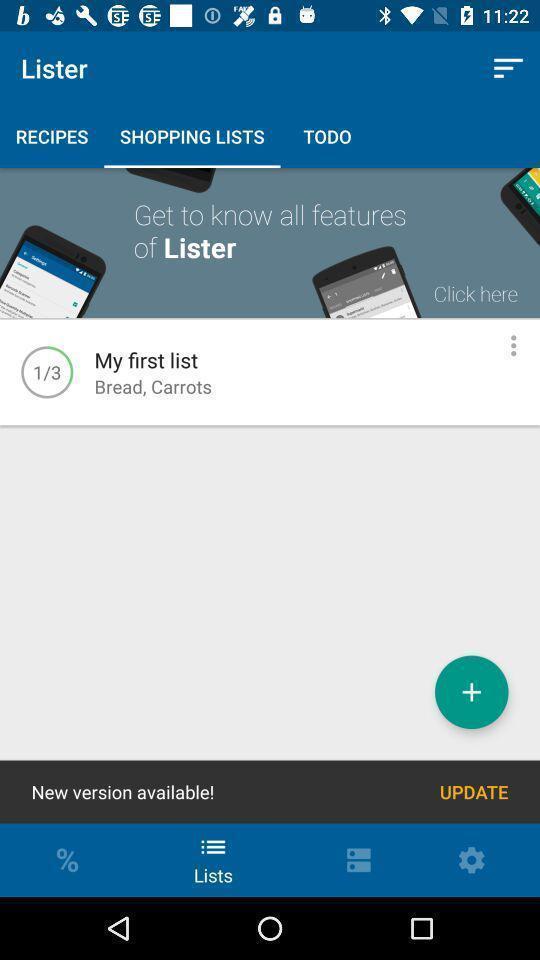Describe this image in words. Shopping app displayed shopping lists and other options. 